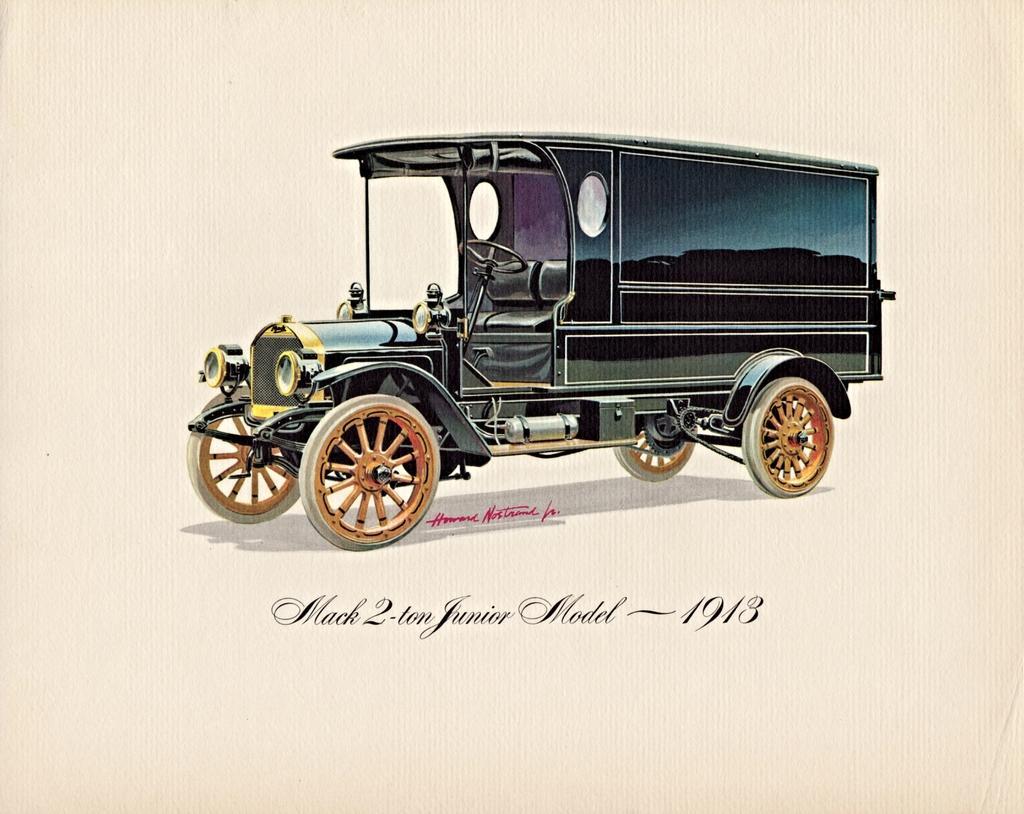Please provide a concise description of this image. In this picture I can see a paper, there are words, numbers and there is an image of a vehicle on the paper. 